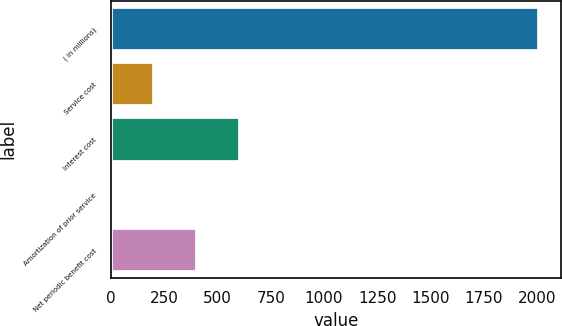<chart> <loc_0><loc_0><loc_500><loc_500><bar_chart><fcel>( in millions)<fcel>Service cost<fcel>Interest cost<fcel>Amortization of prior service<fcel>Net periodic benefit cost<nl><fcel>2010<fcel>201.99<fcel>603.77<fcel>1.1<fcel>402.88<nl></chart> 